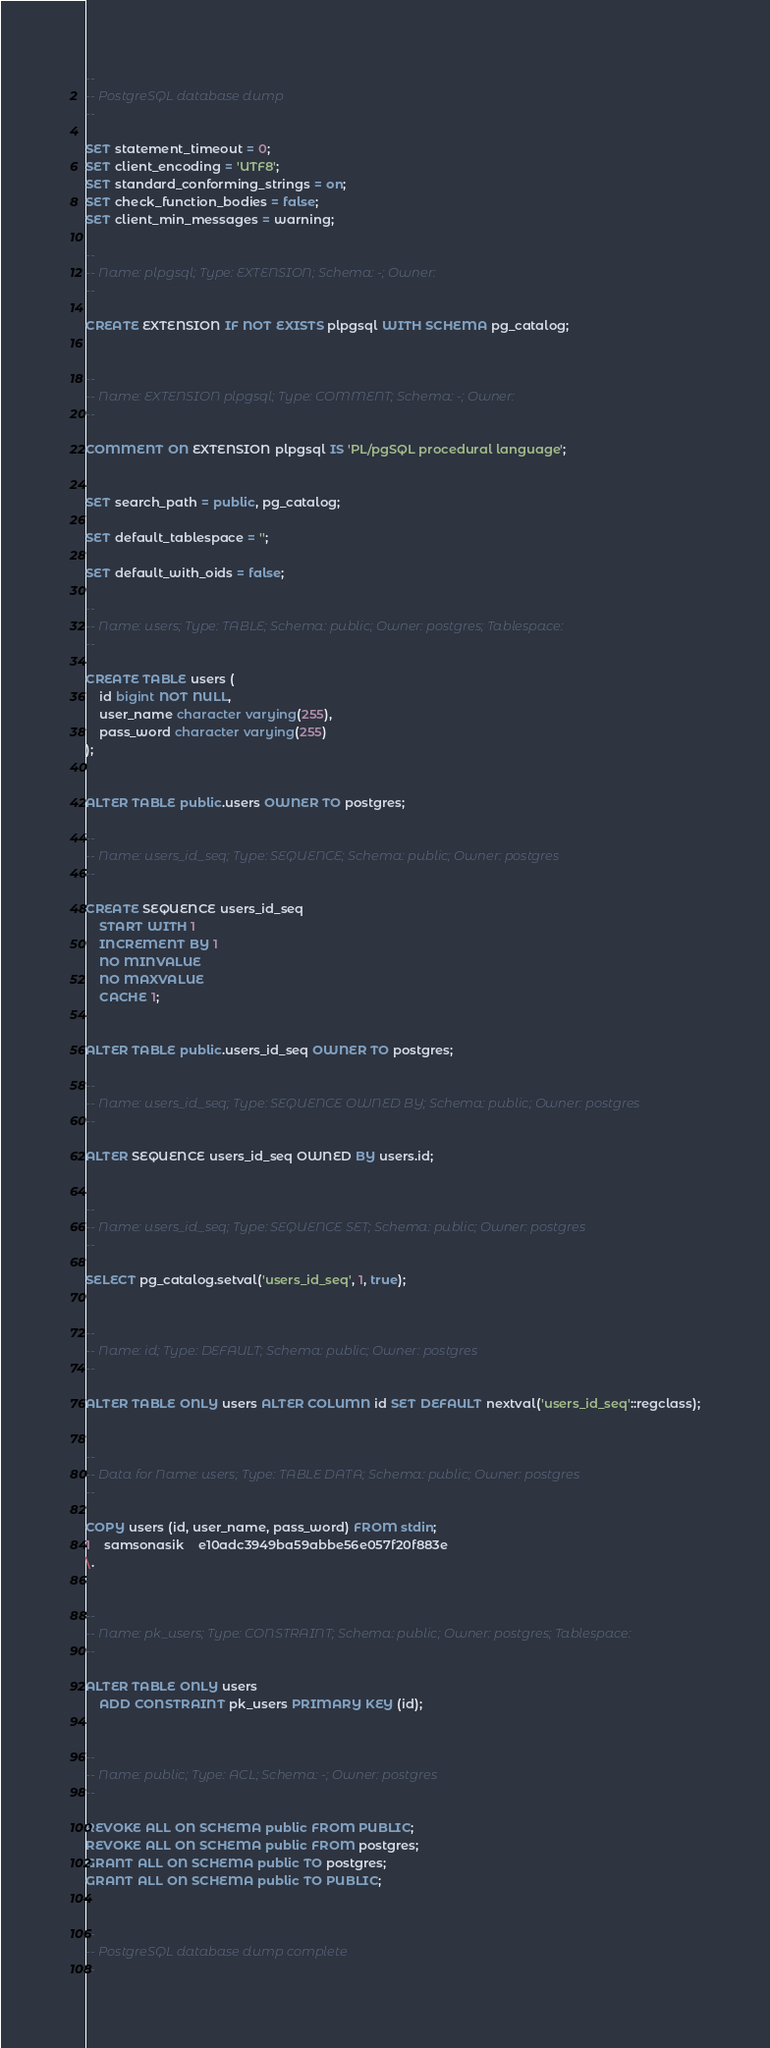Convert code to text. <code><loc_0><loc_0><loc_500><loc_500><_SQL_>--
-- PostgreSQL database dump
--

SET statement_timeout = 0;
SET client_encoding = 'UTF8';
SET standard_conforming_strings = on;
SET check_function_bodies = false;
SET client_min_messages = warning;

--
-- Name: plpgsql; Type: EXTENSION; Schema: -; Owner: 
--

CREATE EXTENSION IF NOT EXISTS plpgsql WITH SCHEMA pg_catalog;


--
-- Name: EXTENSION plpgsql; Type: COMMENT; Schema: -; Owner: 
--

COMMENT ON EXTENSION plpgsql IS 'PL/pgSQL procedural language';


SET search_path = public, pg_catalog;

SET default_tablespace = '';

SET default_with_oids = false;

--
-- Name: users; Type: TABLE; Schema: public; Owner: postgres; Tablespace: 
--

CREATE TABLE users (
    id bigint NOT NULL,
    user_name character varying(255),
    pass_word character varying(255)
);


ALTER TABLE public.users OWNER TO postgres;

--
-- Name: users_id_seq; Type: SEQUENCE; Schema: public; Owner: postgres
--

CREATE SEQUENCE users_id_seq
    START WITH 1
    INCREMENT BY 1
    NO MINVALUE
    NO MAXVALUE
    CACHE 1;


ALTER TABLE public.users_id_seq OWNER TO postgres;

--
-- Name: users_id_seq; Type: SEQUENCE OWNED BY; Schema: public; Owner: postgres
--

ALTER SEQUENCE users_id_seq OWNED BY users.id;


--
-- Name: users_id_seq; Type: SEQUENCE SET; Schema: public; Owner: postgres
--

SELECT pg_catalog.setval('users_id_seq', 1, true);


--
-- Name: id; Type: DEFAULT; Schema: public; Owner: postgres
--

ALTER TABLE ONLY users ALTER COLUMN id SET DEFAULT nextval('users_id_seq'::regclass);


--
-- Data for Name: users; Type: TABLE DATA; Schema: public; Owner: postgres
--

COPY users (id, user_name, pass_word) FROM stdin;
1	samsonasik	e10adc3949ba59abbe56e057f20f883e
\.


--
-- Name: pk_users; Type: CONSTRAINT; Schema: public; Owner: postgres; Tablespace: 
--

ALTER TABLE ONLY users
    ADD CONSTRAINT pk_users PRIMARY KEY (id);


--
-- Name: public; Type: ACL; Schema: -; Owner: postgres
--

REVOKE ALL ON SCHEMA public FROM PUBLIC;
REVOKE ALL ON SCHEMA public FROM postgres;
GRANT ALL ON SCHEMA public TO postgres;
GRANT ALL ON SCHEMA public TO PUBLIC;


--
-- PostgreSQL database dump complete
--

</code> 